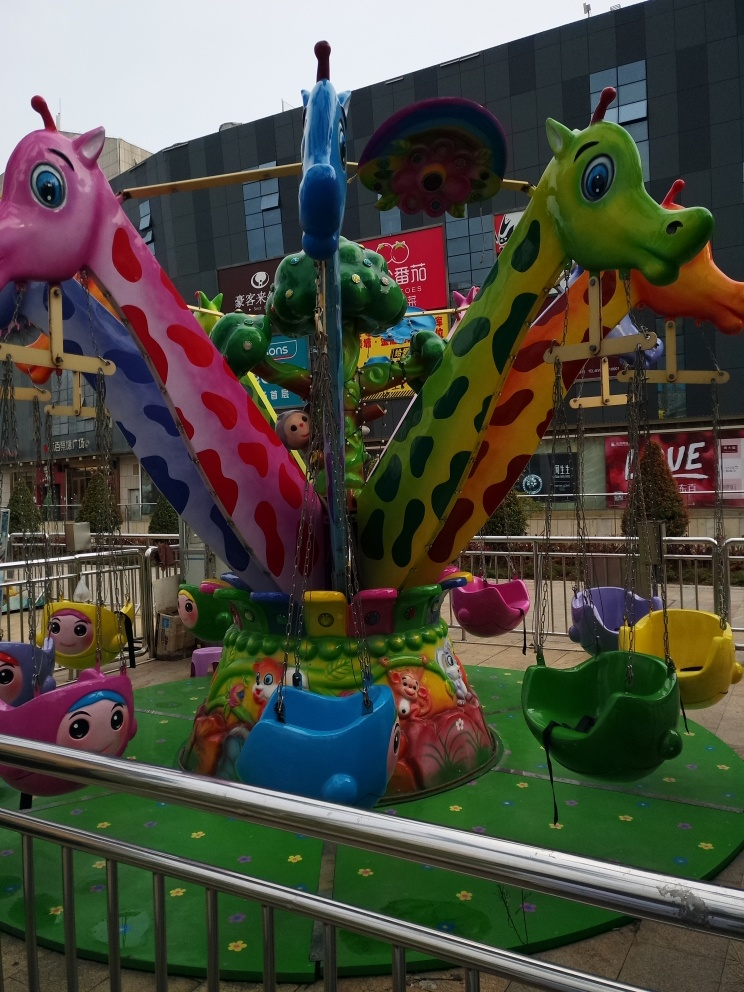Can you describe the style of this carousel? Absolutely, the carousel exhibits a playful and imaginative style with fantastical elements. The animals are not realistic but rather cartoonish with exaggerated features, such as the oversized eyes and vibrant, non-natural colors. The design caters to children's love for whimsy and fantasy. 